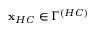<formula> <loc_0><loc_0><loc_500><loc_500>x _ { H C } \in \Gamma ^ { \left ( H C \right ) }</formula> 